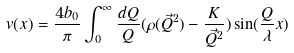<formula> <loc_0><loc_0><loc_500><loc_500>v ( x ) = \frac { 4 b _ { 0 } } { \pi } \int ^ { \infty } _ { 0 } \frac { d Q } { Q } ( \rho ( \vec { Q } ^ { 2 } ) - \frac { K } { \vec { Q } ^ { 2 } } ) \sin ( \frac { Q } { \lambda } x )</formula> 